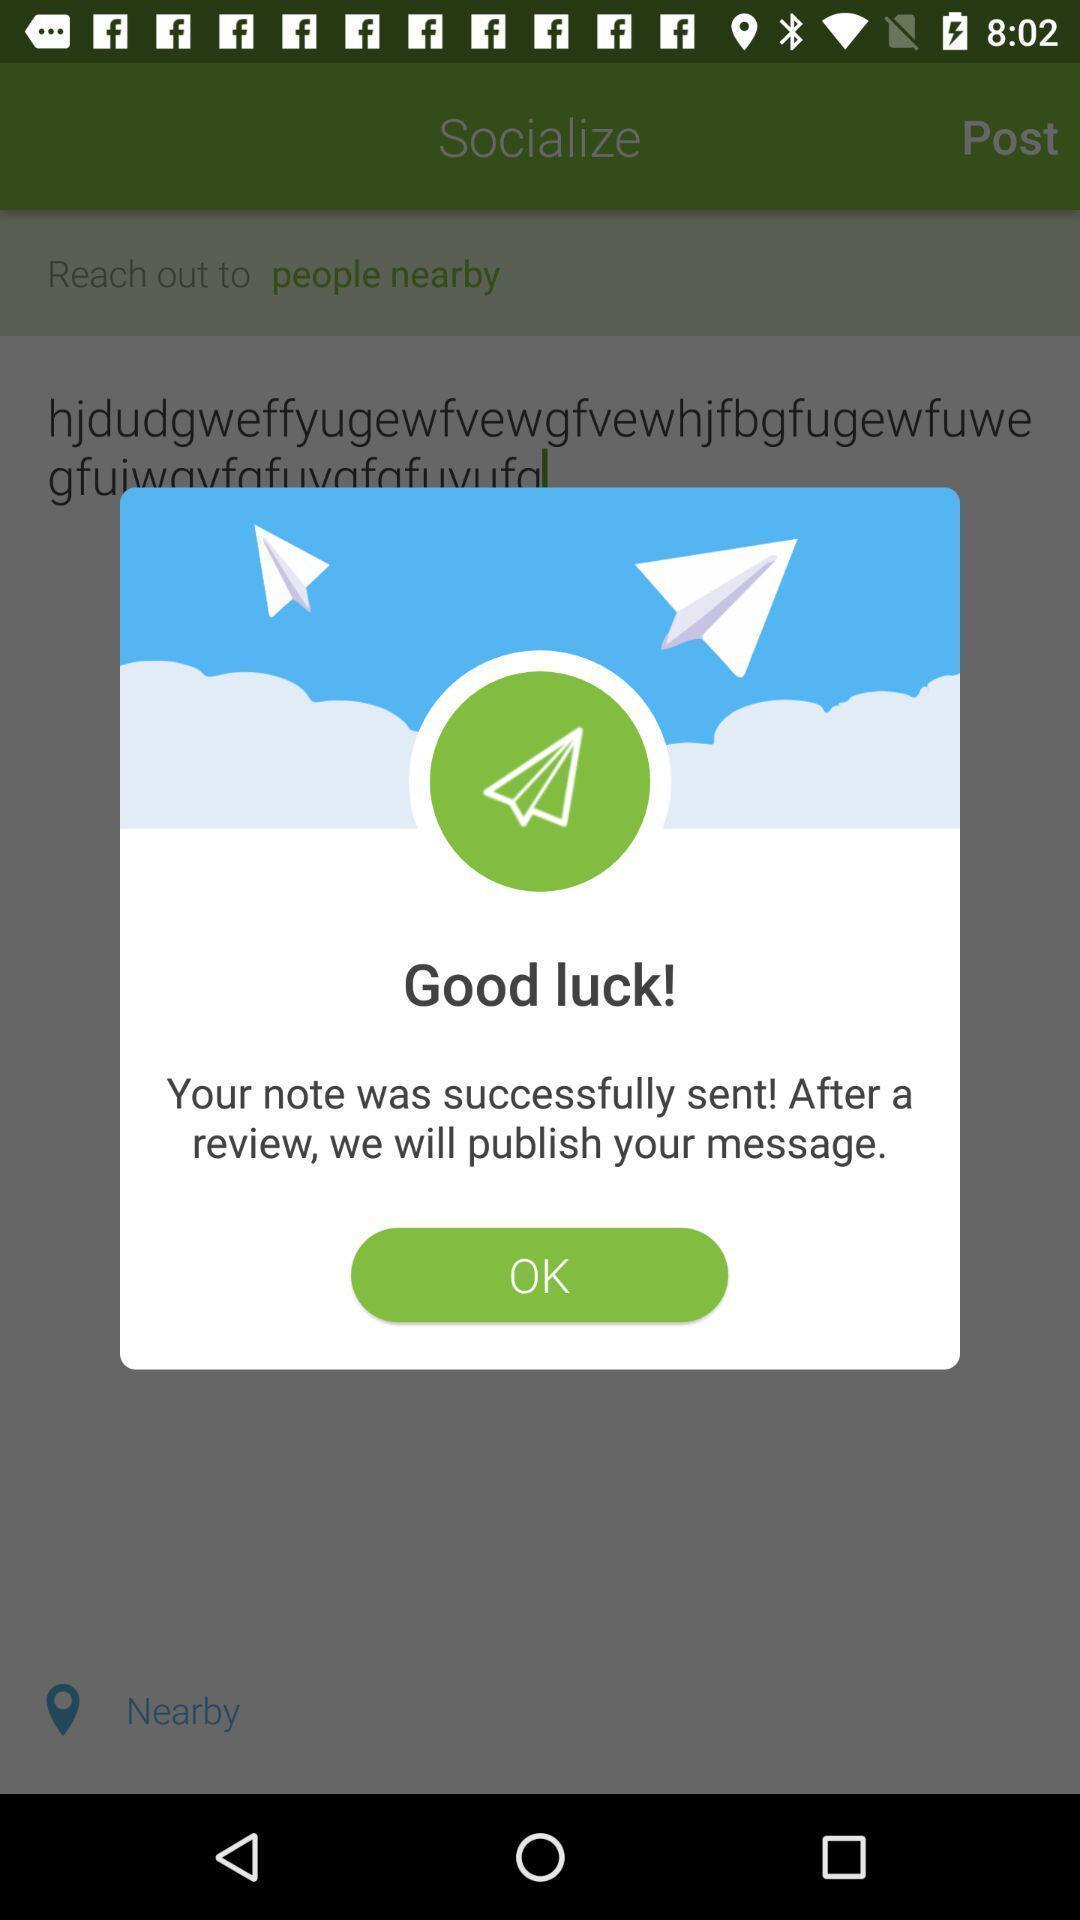Provide a description of this screenshot. Pop-up with info in a friend finder app. 